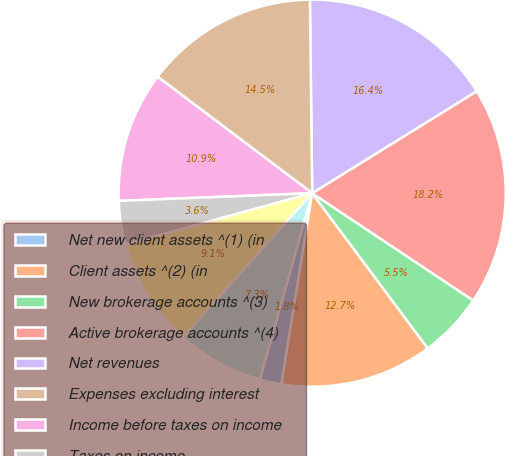Convert chart to OTSL. <chart><loc_0><loc_0><loc_500><loc_500><pie_chart><fcel>Net new client assets ^(1) (in<fcel>Client assets ^(2) (in<fcel>New brokerage accounts ^(3)<fcel>Active brokerage accounts ^(4)<fcel>Net revenues<fcel>Expenses excluding interest<fcel>Income before taxes on income<fcel>Taxes on income<fcel>Net income<fcel>Net income available to common<nl><fcel>1.82%<fcel>12.73%<fcel>5.46%<fcel>18.18%<fcel>16.36%<fcel>14.54%<fcel>10.91%<fcel>3.64%<fcel>9.09%<fcel>7.27%<nl></chart> 